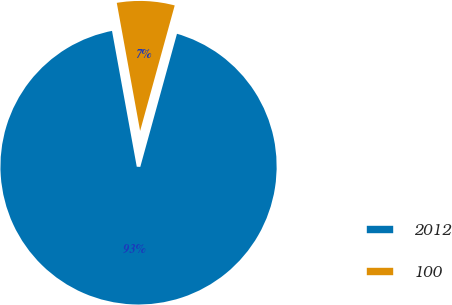<chart> <loc_0><loc_0><loc_500><loc_500><pie_chart><fcel>2012<fcel>100<nl><fcel>92.85%<fcel>7.15%<nl></chart> 